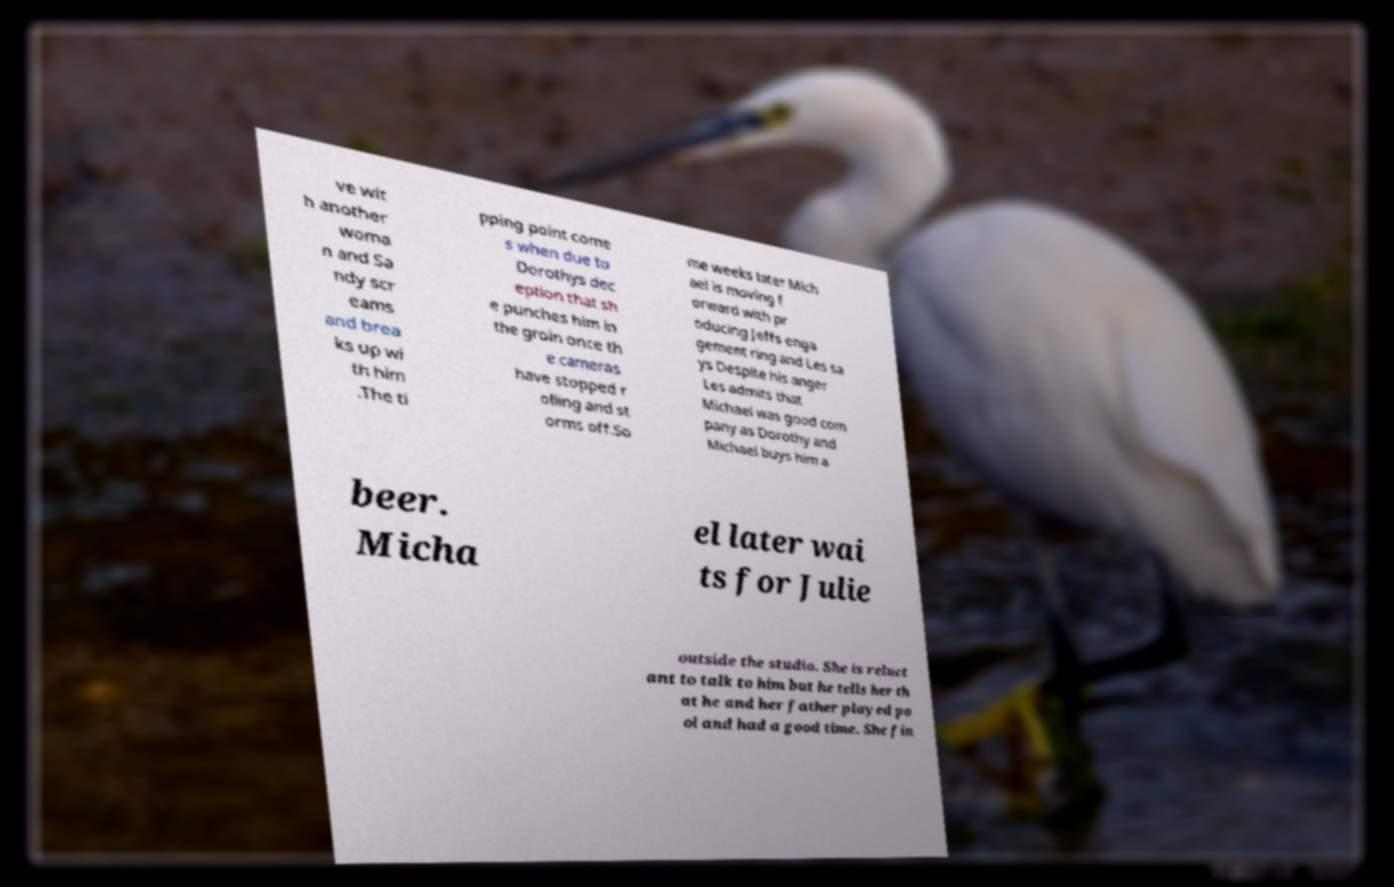Please identify and transcribe the text found in this image. ve wit h another woma n and Sa ndy scr eams and brea ks up wi th him .The ti pping point come s when due to Dorothys dec eption that sh e punches him in the groin once th e cameras have stopped r olling and st orms off.So me weeks later Mich ael is moving f orward with pr oducing Jeffs enga gement ring and Les sa ys Despite his anger Les admits that Michael was good com pany as Dorothy and Michael buys him a beer. Micha el later wai ts for Julie outside the studio. She is reluct ant to talk to him but he tells her th at he and her father played po ol and had a good time. She fin 